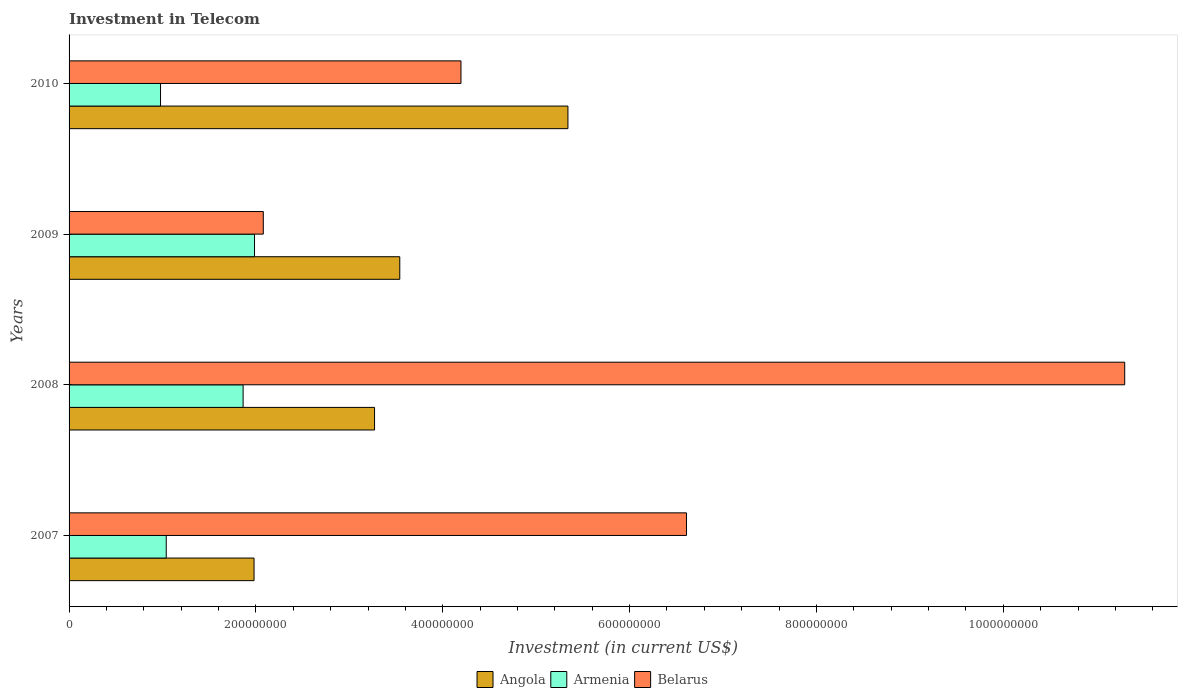How many different coloured bars are there?
Your answer should be compact. 3. Are the number of bars per tick equal to the number of legend labels?
Offer a terse response. Yes. Are the number of bars on each tick of the Y-axis equal?
Your response must be concise. Yes. What is the label of the 4th group of bars from the top?
Your answer should be compact. 2007. In how many cases, is the number of bars for a given year not equal to the number of legend labels?
Give a very brief answer. 0. What is the amount invested in telecom in Angola in 2009?
Give a very brief answer. 3.54e+08. Across all years, what is the maximum amount invested in telecom in Angola?
Offer a very short reply. 5.34e+08. Across all years, what is the minimum amount invested in telecom in Armenia?
Keep it short and to the point. 9.79e+07. In which year was the amount invested in telecom in Armenia maximum?
Give a very brief answer. 2009. What is the total amount invested in telecom in Armenia in the graph?
Give a very brief answer. 5.87e+08. What is the difference between the amount invested in telecom in Angola in 2007 and that in 2009?
Your response must be concise. -1.56e+08. What is the difference between the amount invested in telecom in Belarus in 2010 and the amount invested in telecom in Angola in 2009?
Keep it short and to the point. 6.55e+07. What is the average amount invested in telecom in Angola per year?
Keep it short and to the point. 3.53e+08. In the year 2008, what is the difference between the amount invested in telecom in Angola and amount invested in telecom in Belarus?
Your response must be concise. -8.03e+08. In how many years, is the amount invested in telecom in Angola greater than 480000000 US$?
Provide a short and direct response. 1. What is the ratio of the amount invested in telecom in Angola in 2008 to that in 2010?
Ensure brevity in your answer.  0.61. What is the difference between the highest and the second highest amount invested in telecom in Belarus?
Make the answer very short. 4.69e+08. What is the difference between the highest and the lowest amount invested in telecom in Angola?
Provide a short and direct response. 3.36e+08. What does the 2nd bar from the top in 2009 represents?
Keep it short and to the point. Armenia. What does the 1st bar from the bottom in 2007 represents?
Your answer should be very brief. Angola. How many bars are there?
Offer a terse response. 12. Does the graph contain grids?
Offer a very short reply. No. How are the legend labels stacked?
Offer a very short reply. Horizontal. What is the title of the graph?
Make the answer very short. Investment in Telecom. Does "Zambia" appear as one of the legend labels in the graph?
Keep it short and to the point. No. What is the label or title of the X-axis?
Provide a short and direct response. Investment (in current US$). What is the label or title of the Y-axis?
Your answer should be compact. Years. What is the Investment (in current US$) of Angola in 2007?
Ensure brevity in your answer.  1.98e+08. What is the Investment (in current US$) in Armenia in 2007?
Offer a terse response. 1.04e+08. What is the Investment (in current US$) of Belarus in 2007?
Provide a short and direct response. 6.61e+08. What is the Investment (in current US$) in Angola in 2008?
Ensure brevity in your answer.  3.27e+08. What is the Investment (in current US$) in Armenia in 2008?
Ensure brevity in your answer.  1.86e+08. What is the Investment (in current US$) of Belarus in 2008?
Your response must be concise. 1.13e+09. What is the Investment (in current US$) in Angola in 2009?
Offer a terse response. 3.54e+08. What is the Investment (in current US$) in Armenia in 2009?
Ensure brevity in your answer.  1.98e+08. What is the Investment (in current US$) in Belarus in 2009?
Your response must be concise. 2.08e+08. What is the Investment (in current US$) of Angola in 2010?
Give a very brief answer. 5.34e+08. What is the Investment (in current US$) in Armenia in 2010?
Your response must be concise. 9.79e+07. What is the Investment (in current US$) of Belarus in 2010?
Ensure brevity in your answer.  4.20e+08. Across all years, what is the maximum Investment (in current US$) in Angola?
Your answer should be very brief. 5.34e+08. Across all years, what is the maximum Investment (in current US$) in Armenia?
Your answer should be compact. 1.98e+08. Across all years, what is the maximum Investment (in current US$) of Belarus?
Offer a very short reply. 1.13e+09. Across all years, what is the minimum Investment (in current US$) of Angola?
Make the answer very short. 1.98e+08. Across all years, what is the minimum Investment (in current US$) in Armenia?
Your answer should be very brief. 9.79e+07. Across all years, what is the minimum Investment (in current US$) in Belarus?
Your response must be concise. 2.08e+08. What is the total Investment (in current US$) of Angola in the graph?
Offer a very short reply. 1.41e+09. What is the total Investment (in current US$) of Armenia in the graph?
Give a very brief answer. 5.87e+08. What is the total Investment (in current US$) in Belarus in the graph?
Give a very brief answer. 2.42e+09. What is the difference between the Investment (in current US$) in Angola in 2007 and that in 2008?
Ensure brevity in your answer.  -1.29e+08. What is the difference between the Investment (in current US$) in Armenia in 2007 and that in 2008?
Your answer should be compact. -8.23e+07. What is the difference between the Investment (in current US$) in Belarus in 2007 and that in 2008?
Offer a terse response. -4.69e+08. What is the difference between the Investment (in current US$) in Angola in 2007 and that in 2009?
Ensure brevity in your answer.  -1.56e+08. What is the difference between the Investment (in current US$) in Armenia in 2007 and that in 2009?
Offer a very short reply. -9.45e+07. What is the difference between the Investment (in current US$) of Belarus in 2007 and that in 2009?
Offer a terse response. 4.53e+08. What is the difference between the Investment (in current US$) of Angola in 2007 and that in 2010?
Keep it short and to the point. -3.36e+08. What is the difference between the Investment (in current US$) in Armenia in 2007 and that in 2010?
Offer a very short reply. 6.10e+06. What is the difference between the Investment (in current US$) of Belarus in 2007 and that in 2010?
Provide a succinct answer. 2.41e+08. What is the difference between the Investment (in current US$) of Angola in 2008 and that in 2009?
Ensure brevity in your answer.  -2.70e+07. What is the difference between the Investment (in current US$) in Armenia in 2008 and that in 2009?
Your answer should be very brief. -1.22e+07. What is the difference between the Investment (in current US$) in Belarus in 2008 and that in 2009?
Ensure brevity in your answer.  9.22e+08. What is the difference between the Investment (in current US$) of Angola in 2008 and that in 2010?
Keep it short and to the point. -2.07e+08. What is the difference between the Investment (in current US$) of Armenia in 2008 and that in 2010?
Offer a very short reply. 8.84e+07. What is the difference between the Investment (in current US$) of Belarus in 2008 and that in 2010?
Ensure brevity in your answer.  7.10e+08. What is the difference between the Investment (in current US$) of Angola in 2009 and that in 2010?
Keep it short and to the point. -1.80e+08. What is the difference between the Investment (in current US$) of Armenia in 2009 and that in 2010?
Keep it short and to the point. 1.01e+08. What is the difference between the Investment (in current US$) of Belarus in 2009 and that in 2010?
Provide a succinct answer. -2.12e+08. What is the difference between the Investment (in current US$) in Angola in 2007 and the Investment (in current US$) in Armenia in 2008?
Offer a terse response. 1.17e+07. What is the difference between the Investment (in current US$) of Angola in 2007 and the Investment (in current US$) of Belarus in 2008?
Offer a very short reply. -9.32e+08. What is the difference between the Investment (in current US$) in Armenia in 2007 and the Investment (in current US$) in Belarus in 2008?
Offer a very short reply. -1.03e+09. What is the difference between the Investment (in current US$) of Angola in 2007 and the Investment (in current US$) of Armenia in 2009?
Your answer should be very brief. -5.00e+05. What is the difference between the Investment (in current US$) in Angola in 2007 and the Investment (in current US$) in Belarus in 2009?
Offer a terse response. -9.90e+06. What is the difference between the Investment (in current US$) of Armenia in 2007 and the Investment (in current US$) of Belarus in 2009?
Your answer should be very brief. -1.04e+08. What is the difference between the Investment (in current US$) in Angola in 2007 and the Investment (in current US$) in Armenia in 2010?
Offer a terse response. 1.00e+08. What is the difference between the Investment (in current US$) of Angola in 2007 and the Investment (in current US$) of Belarus in 2010?
Keep it short and to the point. -2.22e+08. What is the difference between the Investment (in current US$) in Armenia in 2007 and the Investment (in current US$) in Belarus in 2010?
Keep it short and to the point. -3.16e+08. What is the difference between the Investment (in current US$) in Angola in 2008 and the Investment (in current US$) in Armenia in 2009?
Provide a succinct answer. 1.28e+08. What is the difference between the Investment (in current US$) of Angola in 2008 and the Investment (in current US$) of Belarus in 2009?
Provide a short and direct response. 1.19e+08. What is the difference between the Investment (in current US$) in Armenia in 2008 and the Investment (in current US$) in Belarus in 2009?
Make the answer very short. -2.16e+07. What is the difference between the Investment (in current US$) of Angola in 2008 and the Investment (in current US$) of Armenia in 2010?
Provide a succinct answer. 2.29e+08. What is the difference between the Investment (in current US$) in Angola in 2008 and the Investment (in current US$) in Belarus in 2010?
Give a very brief answer. -9.25e+07. What is the difference between the Investment (in current US$) of Armenia in 2008 and the Investment (in current US$) of Belarus in 2010?
Make the answer very short. -2.33e+08. What is the difference between the Investment (in current US$) in Angola in 2009 and the Investment (in current US$) in Armenia in 2010?
Give a very brief answer. 2.56e+08. What is the difference between the Investment (in current US$) of Angola in 2009 and the Investment (in current US$) of Belarus in 2010?
Give a very brief answer. -6.55e+07. What is the difference between the Investment (in current US$) of Armenia in 2009 and the Investment (in current US$) of Belarus in 2010?
Your response must be concise. -2.21e+08. What is the average Investment (in current US$) in Angola per year?
Make the answer very short. 3.53e+08. What is the average Investment (in current US$) of Armenia per year?
Ensure brevity in your answer.  1.47e+08. What is the average Investment (in current US$) in Belarus per year?
Provide a succinct answer. 6.05e+08. In the year 2007, what is the difference between the Investment (in current US$) of Angola and Investment (in current US$) of Armenia?
Offer a very short reply. 9.40e+07. In the year 2007, what is the difference between the Investment (in current US$) in Angola and Investment (in current US$) in Belarus?
Your answer should be very brief. -4.63e+08. In the year 2007, what is the difference between the Investment (in current US$) of Armenia and Investment (in current US$) of Belarus?
Offer a terse response. -5.57e+08. In the year 2008, what is the difference between the Investment (in current US$) of Angola and Investment (in current US$) of Armenia?
Your response must be concise. 1.41e+08. In the year 2008, what is the difference between the Investment (in current US$) of Angola and Investment (in current US$) of Belarus?
Your response must be concise. -8.03e+08. In the year 2008, what is the difference between the Investment (in current US$) of Armenia and Investment (in current US$) of Belarus?
Give a very brief answer. -9.44e+08. In the year 2009, what is the difference between the Investment (in current US$) of Angola and Investment (in current US$) of Armenia?
Offer a very short reply. 1.56e+08. In the year 2009, what is the difference between the Investment (in current US$) in Angola and Investment (in current US$) in Belarus?
Ensure brevity in your answer.  1.46e+08. In the year 2009, what is the difference between the Investment (in current US$) in Armenia and Investment (in current US$) in Belarus?
Keep it short and to the point. -9.40e+06. In the year 2010, what is the difference between the Investment (in current US$) of Angola and Investment (in current US$) of Armenia?
Your answer should be very brief. 4.36e+08. In the year 2010, what is the difference between the Investment (in current US$) in Angola and Investment (in current US$) in Belarus?
Provide a succinct answer. 1.14e+08. In the year 2010, what is the difference between the Investment (in current US$) of Armenia and Investment (in current US$) of Belarus?
Offer a terse response. -3.22e+08. What is the ratio of the Investment (in current US$) in Angola in 2007 to that in 2008?
Ensure brevity in your answer.  0.61. What is the ratio of the Investment (in current US$) of Armenia in 2007 to that in 2008?
Provide a short and direct response. 0.56. What is the ratio of the Investment (in current US$) in Belarus in 2007 to that in 2008?
Your response must be concise. 0.58. What is the ratio of the Investment (in current US$) of Angola in 2007 to that in 2009?
Your answer should be compact. 0.56. What is the ratio of the Investment (in current US$) in Armenia in 2007 to that in 2009?
Your answer should be compact. 0.52. What is the ratio of the Investment (in current US$) of Belarus in 2007 to that in 2009?
Your answer should be very brief. 3.18. What is the ratio of the Investment (in current US$) in Angola in 2007 to that in 2010?
Ensure brevity in your answer.  0.37. What is the ratio of the Investment (in current US$) of Armenia in 2007 to that in 2010?
Make the answer very short. 1.06. What is the ratio of the Investment (in current US$) of Belarus in 2007 to that in 2010?
Your response must be concise. 1.58. What is the ratio of the Investment (in current US$) in Angola in 2008 to that in 2009?
Your response must be concise. 0.92. What is the ratio of the Investment (in current US$) in Armenia in 2008 to that in 2009?
Your response must be concise. 0.94. What is the ratio of the Investment (in current US$) in Belarus in 2008 to that in 2009?
Provide a short and direct response. 5.44. What is the ratio of the Investment (in current US$) in Angola in 2008 to that in 2010?
Offer a very short reply. 0.61. What is the ratio of the Investment (in current US$) in Armenia in 2008 to that in 2010?
Your response must be concise. 1.9. What is the ratio of the Investment (in current US$) of Belarus in 2008 to that in 2010?
Your response must be concise. 2.69. What is the ratio of the Investment (in current US$) in Angola in 2009 to that in 2010?
Ensure brevity in your answer.  0.66. What is the ratio of the Investment (in current US$) of Armenia in 2009 to that in 2010?
Your response must be concise. 2.03. What is the ratio of the Investment (in current US$) in Belarus in 2009 to that in 2010?
Ensure brevity in your answer.  0.5. What is the difference between the highest and the second highest Investment (in current US$) in Angola?
Keep it short and to the point. 1.80e+08. What is the difference between the highest and the second highest Investment (in current US$) in Armenia?
Offer a very short reply. 1.22e+07. What is the difference between the highest and the second highest Investment (in current US$) of Belarus?
Your answer should be compact. 4.69e+08. What is the difference between the highest and the lowest Investment (in current US$) of Angola?
Your answer should be compact. 3.36e+08. What is the difference between the highest and the lowest Investment (in current US$) in Armenia?
Make the answer very short. 1.01e+08. What is the difference between the highest and the lowest Investment (in current US$) of Belarus?
Make the answer very short. 9.22e+08. 